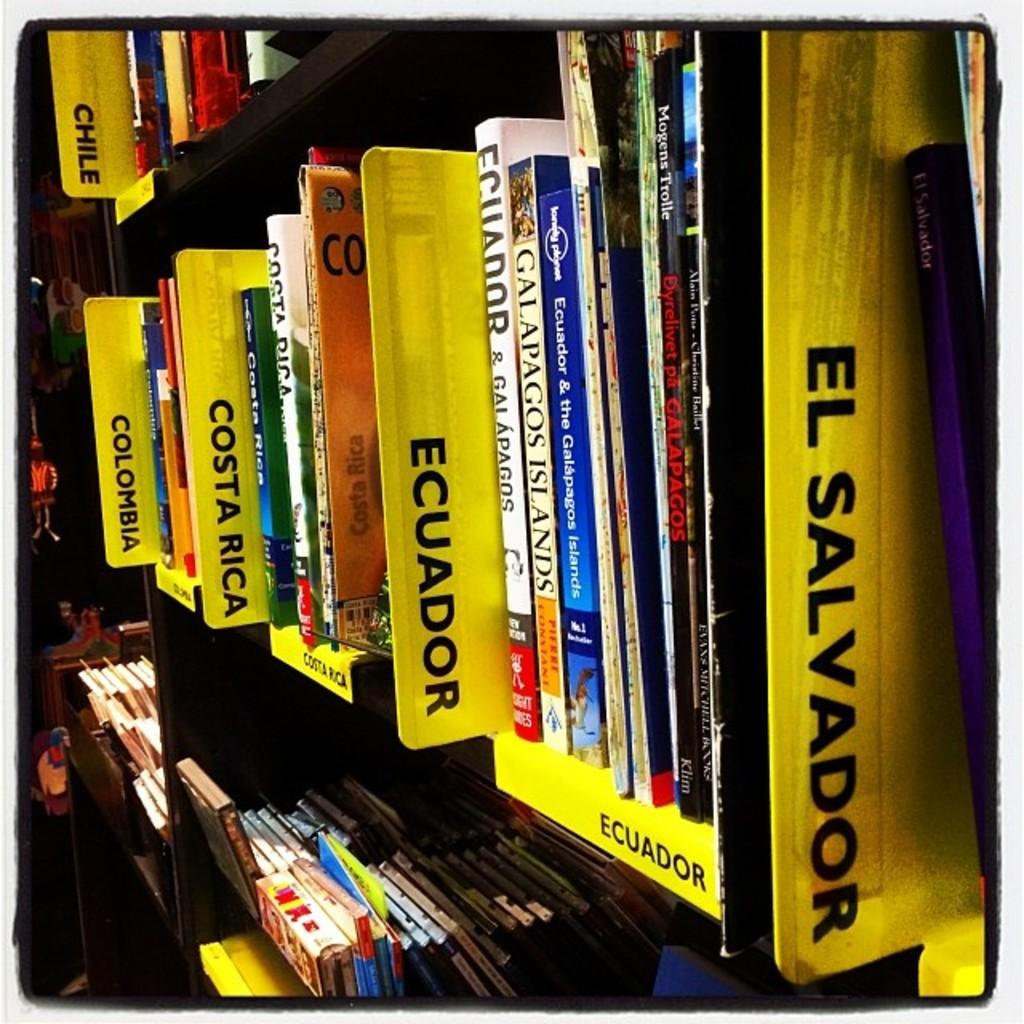<image>
Present a compact description of the photo's key features. Books are divided into sections including El Salvador and Ecuador. 